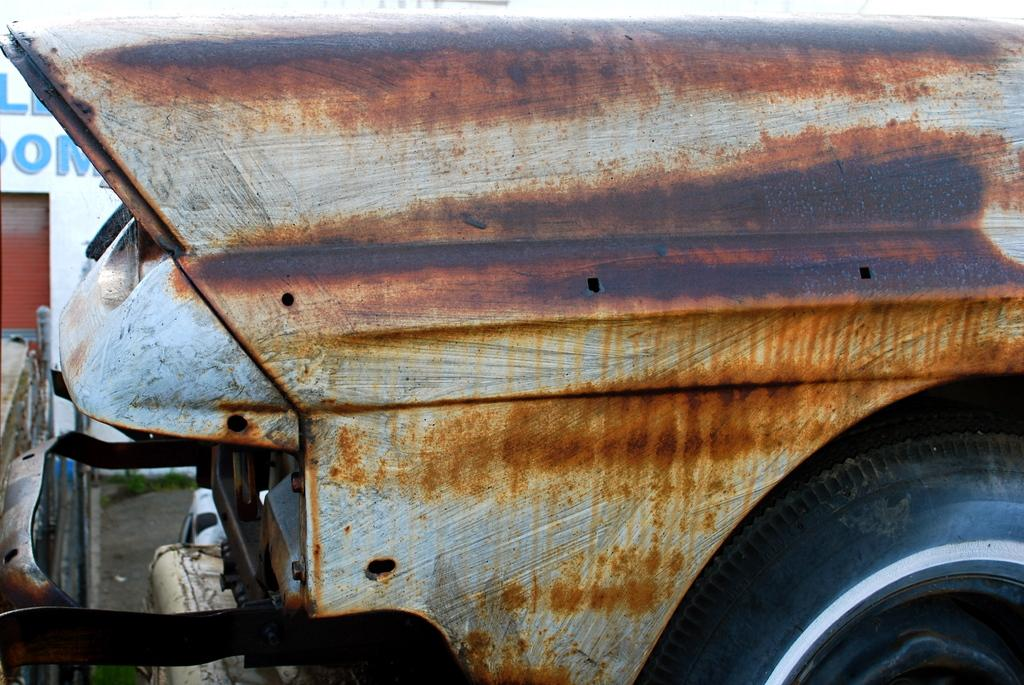What is the main subject of the picture? The main subject of the picture is a wheel of a vehicle. Can you describe any other elements in the picture? Yes, there is a shutter on the top left side of the picture. What type of beef is being served at the minister's uncle's party in the picture? There is no minister, beef, or uncle present in the picture; it only features a wheel of a vehicle and a shutter. 